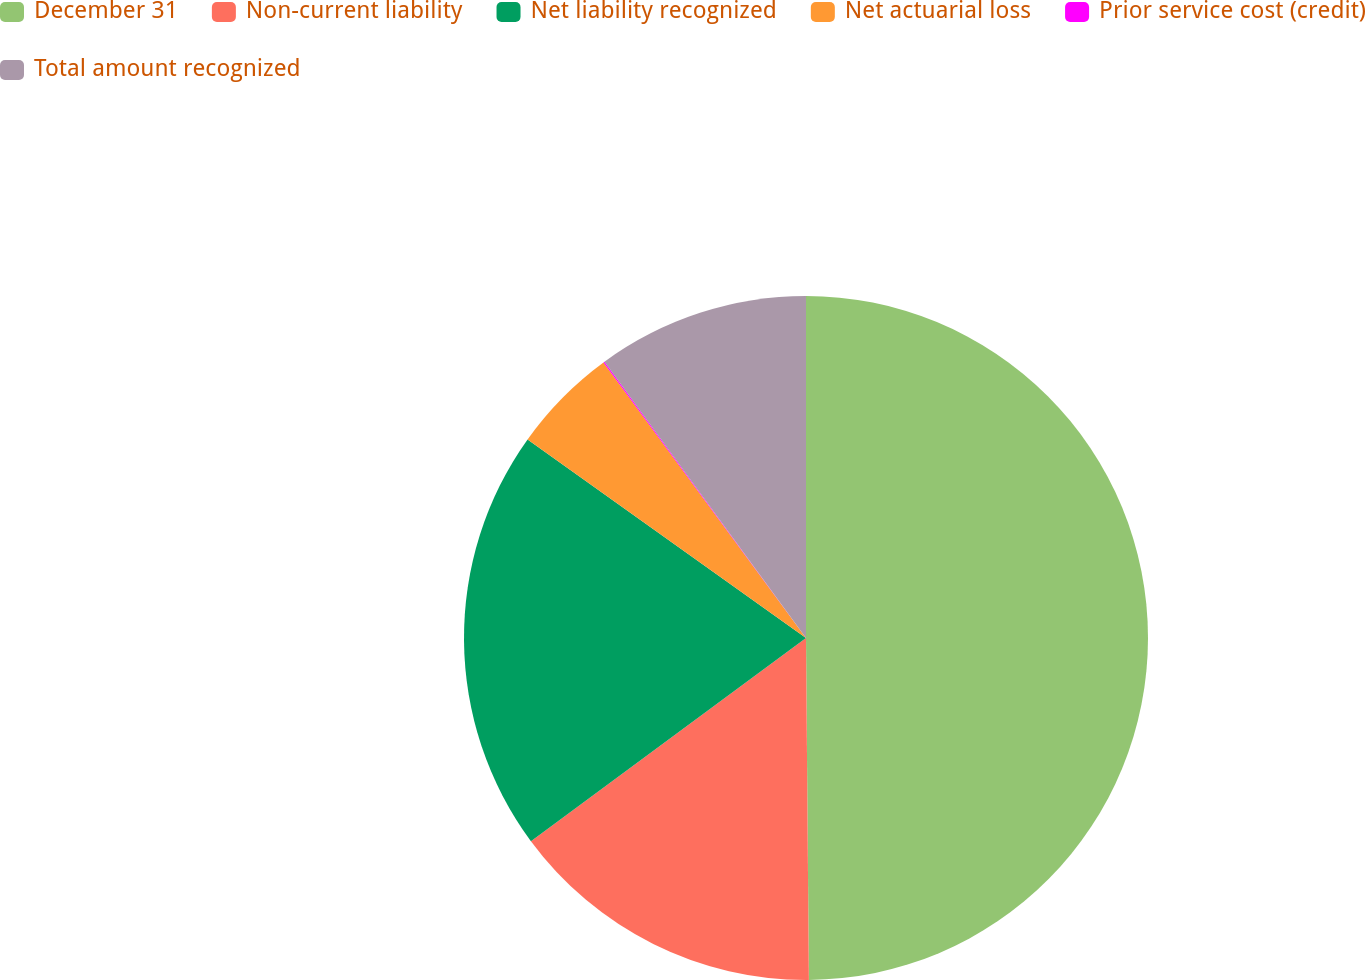<chart> <loc_0><loc_0><loc_500><loc_500><pie_chart><fcel>December 31<fcel>Non-current liability<fcel>Net liability recognized<fcel>Net actuarial loss<fcel>Prior service cost (credit)<fcel>Total amount recognized<nl><fcel>49.87%<fcel>15.01%<fcel>19.99%<fcel>5.05%<fcel>0.06%<fcel>10.03%<nl></chart> 